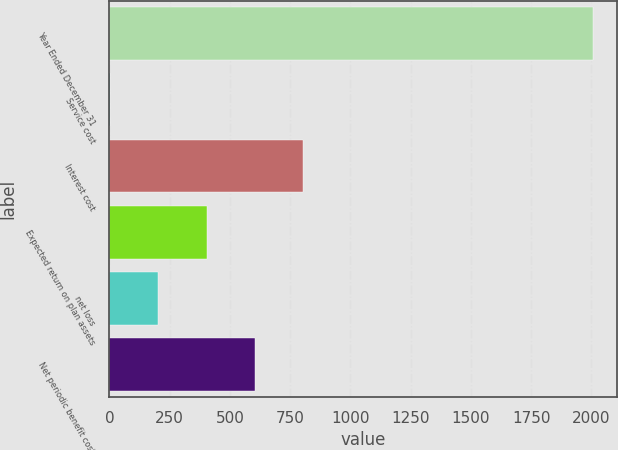Convert chart. <chart><loc_0><loc_0><loc_500><loc_500><bar_chart><fcel>Year Ended December 31<fcel>Service cost<fcel>Interest cost<fcel>Expected return on plan assets<fcel>net loss<fcel>Net periodic benefit cost<nl><fcel>2007<fcel>3<fcel>804.6<fcel>403.8<fcel>203.4<fcel>604.2<nl></chart> 